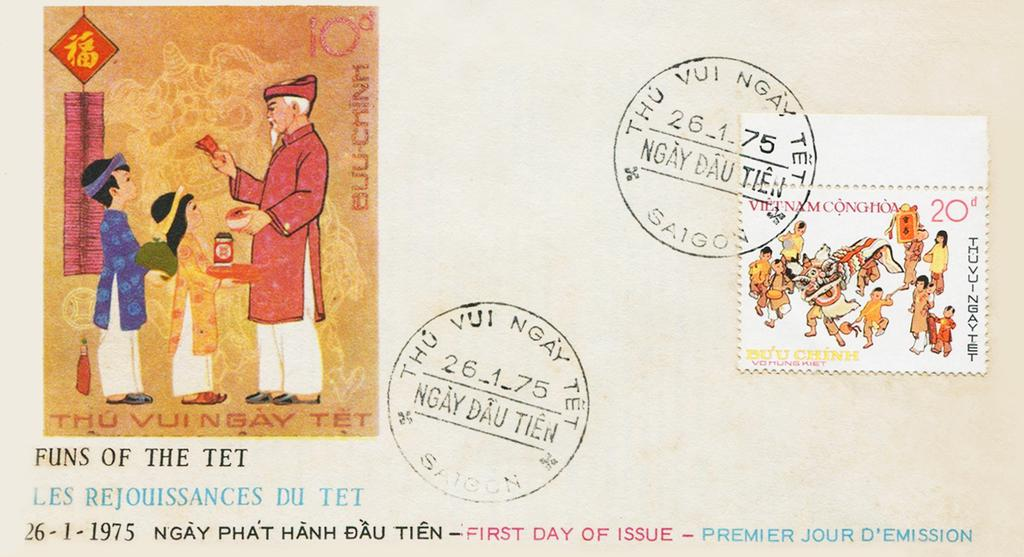<image>
Write a terse but informative summary of the picture. A postcard with a small picture with the text FUNS OF THE TET underneath it. 